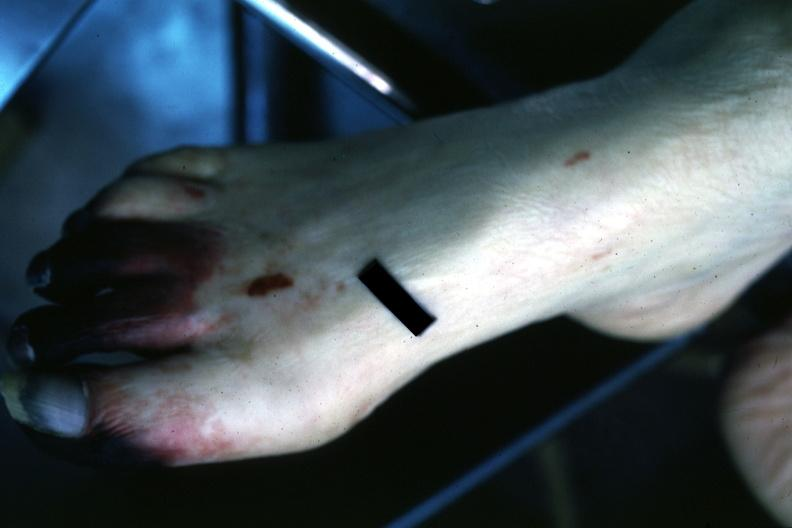does this image show well gangrenous 1-3 toes?
Answer the question using a single word or phrase. Yes 